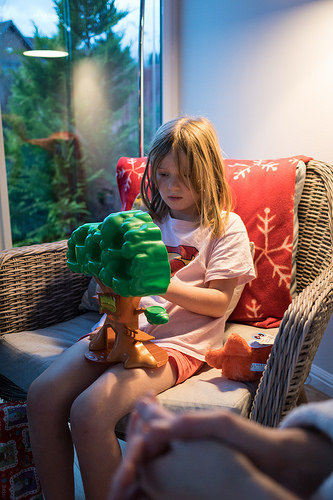<image>
Can you confirm if the girl is behind the tree? No. The girl is not behind the tree. From this viewpoint, the girl appears to be positioned elsewhere in the scene. 